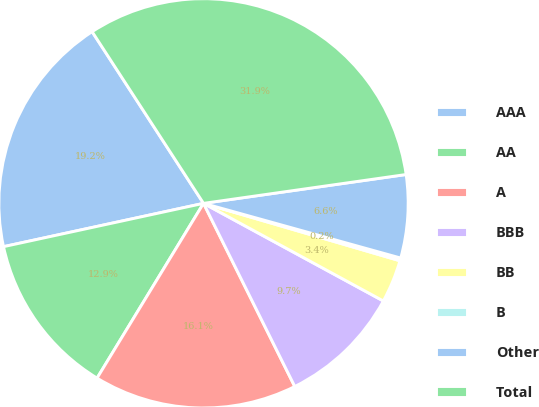Convert chart. <chart><loc_0><loc_0><loc_500><loc_500><pie_chart><fcel>AAA<fcel>AA<fcel>A<fcel>BBB<fcel>BB<fcel>B<fcel>Other<fcel>Total<nl><fcel>19.24%<fcel>12.9%<fcel>16.07%<fcel>9.73%<fcel>3.39%<fcel>0.22%<fcel>6.56%<fcel>31.92%<nl></chart> 